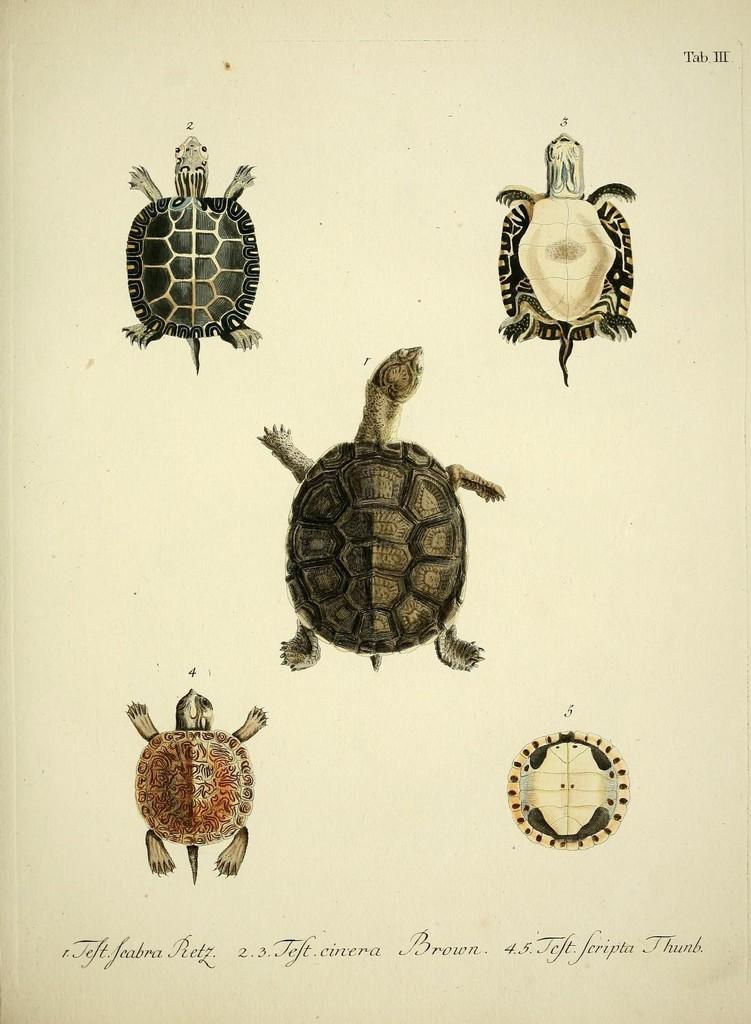How would you summarize this image in a sentence or two? This image is an art done on the paper with different color pencils. At the bottom of the image there is a text. In this image there are a few images of turtles and a tortoise. 